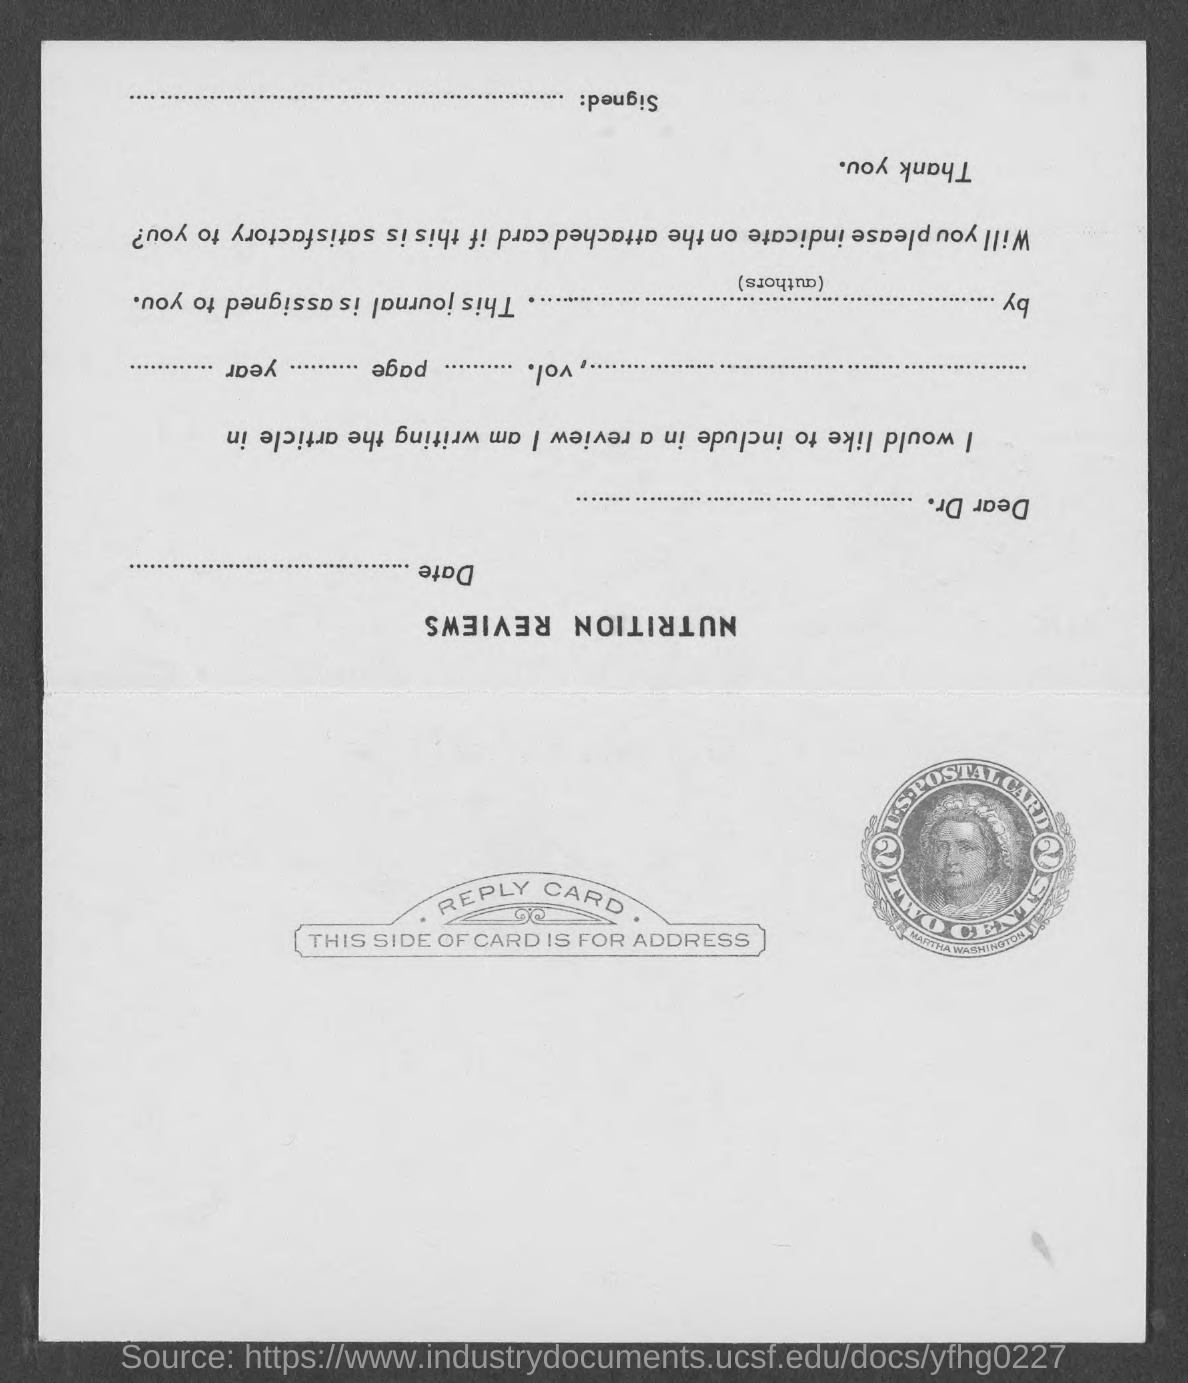Mention a couple of crucial points in this snapshot. The person depicted on the stamp is named Martha Washington. The cost of the stamp on a postal card is TWO CENTS. 